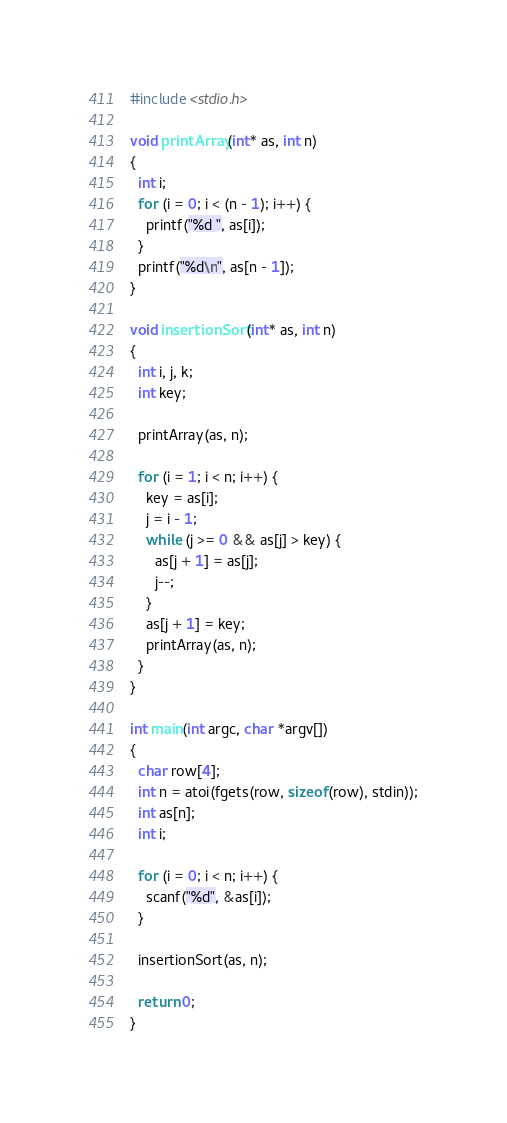<code> <loc_0><loc_0><loc_500><loc_500><_C_>#include <stdio.h>

void printArray(int* as, int n)
{
  int i;
  for (i = 0; i < (n - 1); i++) {
    printf("%d ", as[i]);
  }
  printf("%d\n", as[n - 1]);
}

void insertionSort(int* as, int n)
{
  int i, j, k;
  int key;

  printArray(as, n);

  for (i = 1; i < n; i++) {
    key = as[i];
    j = i - 1;
    while (j >= 0 && as[j] > key) {
      as[j + 1] = as[j];
      j--;
    }
    as[j + 1] = key;
    printArray(as, n);
  }
}

int main(int argc, char *argv[])
{
  char row[4];
  int n = atoi(fgets(row, sizeof(row), stdin));
  int as[n];
  int i;

  for (i = 0; i < n; i++) {
    scanf("%d", &as[i]);
  }

  insertionSort(as, n);

  return 0;
}</code> 